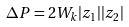<formula> <loc_0><loc_0><loc_500><loc_500>\Delta P = 2 W _ { k } | z _ { 1 } | | z _ { 2 } |</formula> 